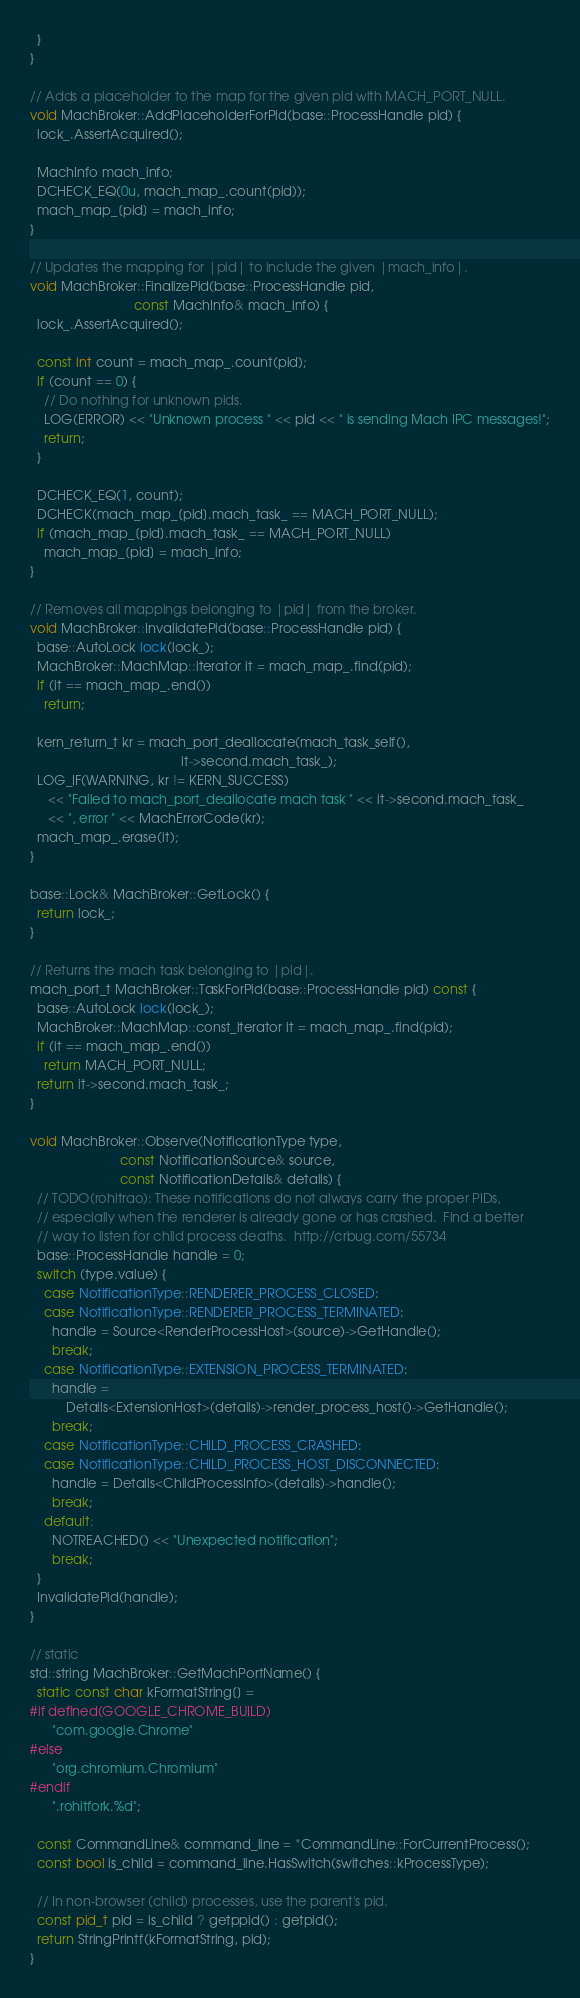<code> <loc_0><loc_0><loc_500><loc_500><_C++_>  }
}

// Adds a placeholder to the map for the given pid with MACH_PORT_NULL.
void MachBroker::AddPlaceholderForPid(base::ProcessHandle pid) {
  lock_.AssertAcquired();

  MachInfo mach_info;
  DCHECK_EQ(0u, mach_map_.count(pid));
  mach_map_[pid] = mach_info;
}

// Updates the mapping for |pid| to include the given |mach_info|.
void MachBroker::FinalizePid(base::ProcessHandle pid,
                             const MachInfo& mach_info) {
  lock_.AssertAcquired();

  const int count = mach_map_.count(pid);
  if (count == 0) {
    // Do nothing for unknown pids.
    LOG(ERROR) << "Unknown process " << pid << " is sending Mach IPC messages!";
    return;
  }

  DCHECK_EQ(1, count);
  DCHECK(mach_map_[pid].mach_task_ == MACH_PORT_NULL);
  if (mach_map_[pid].mach_task_ == MACH_PORT_NULL)
    mach_map_[pid] = mach_info;
}

// Removes all mappings belonging to |pid| from the broker.
void MachBroker::InvalidatePid(base::ProcessHandle pid) {
  base::AutoLock lock(lock_);
  MachBroker::MachMap::iterator it = mach_map_.find(pid);
  if (it == mach_map_.end())
    return;

  kern_return_t kr = mach_port_deallocate(mach_task_self(),
                                          it->second.mach_task_);
  LOG_IF(WARNING, kr != KERN_SUCCESS)
     << "Failed to mach_port_deallocate mach task " << it->second.mach_task_
     << ", error " << MachErrorCode(kr);
  mach_map_.erase(it);
}

base::Lock& MachBroker::GetLock() {
  return lock_;
}

// Returns the mach task belonging to |pid|.
mach_port_t MachBroker::TaskForPid(base::ProcessHandle pid) const {
  base::AutoLock lock(lock_);
  MachBroker::MachMap::const_iterator it = mach_map_.find(pid);
  if (it == mach_map_.end())
    return MACH_PORT_NULL;
  return it->second.mach_task_;
}

void MachBroker::Observe(NotificationType type,
                         const NotificationSource& source,
                         const NotificationDetails& details) {
  // TODO(rohitrao): These notifications do not always carry the proper PIDs,
  // especially when the renderer is already gone or has crashed.  Find a better
  // way to listen for child process deaths.  http://crbug.com/55734
  base::ProcessHandle handle = 0;
  switch (type.value) {
    case NotificationType::RENDERER_PROCESS_CLOSED:
    case NotificationType::RENDERER_PROCESS_TERMINATED:
      handle = Source<RenderProcessHost>(source)->GetHandle();
      break;
    case NotificationType::EXTENSION_PROCESS_TERMINATED:
      handle =
          Details<ExtensionHost>(details)->render_process_host()->GetHandle();
      break;
    case NotificationType::CHILD_PROCESS_CRASHED:
    case NotificationType::CHILD_PROCESS_HOST_DISCONNECTED:
      handle = Details<ChildProcessInfo>(details)->handle();
      break;
    default:
      NOTREACHED() << "Unexpected notification";
      break;
  }
  InvalidatePid(handle);
}

// static
std::string MachBroker::GetMachPortName() {
  static const char kFormatString[] =
#if defined(GOOGLE_CHROME_BUILD)
      "com.google.Chrome"
#else
      "org.chromium.Chromium"
#endif
      ".rohitfork.%d";

  const CommandLine& command_line = *CommandLine::ForCurrentProcess();
  const bool is_child = command_line.HasSwitch(switches::kProcessType);

  // In non-browser (child) processes, use the parent's pid.
  const pid_t pid = is_child ? getppid() : getpid();
  return StringPrintf(kFormatString, pid);
}
</code> 